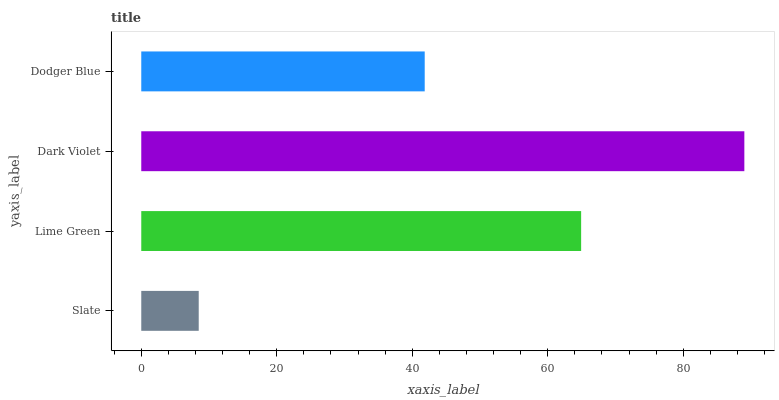Is Slate the minimum?
Answer yes or no. Yes. Is Dark Violet the maximum?
Answer yes or no. Yes. Is Lime Green the minimum?
Answer yes or no. No. Is Lime Green the maximum?
Answer yes or no. No. Is Lime Green greater than Slate?
Answer yes or no. Yes. Is Slate less than Lime Green?
Answer yes or no. Yes. Is Slate greater than Lime Green?
Answer yes or no. No. Is Lime Green less than Slate?
Answer yes or no. No. Is Lime Green the high median?
Answer yes or no. Yes. Is Dodger Blue the low median?
Answer yes or no. Yes. Is Slate the high median?
Answer yes or no. No. Is Slate the low median?
Answer yes or no. No. 